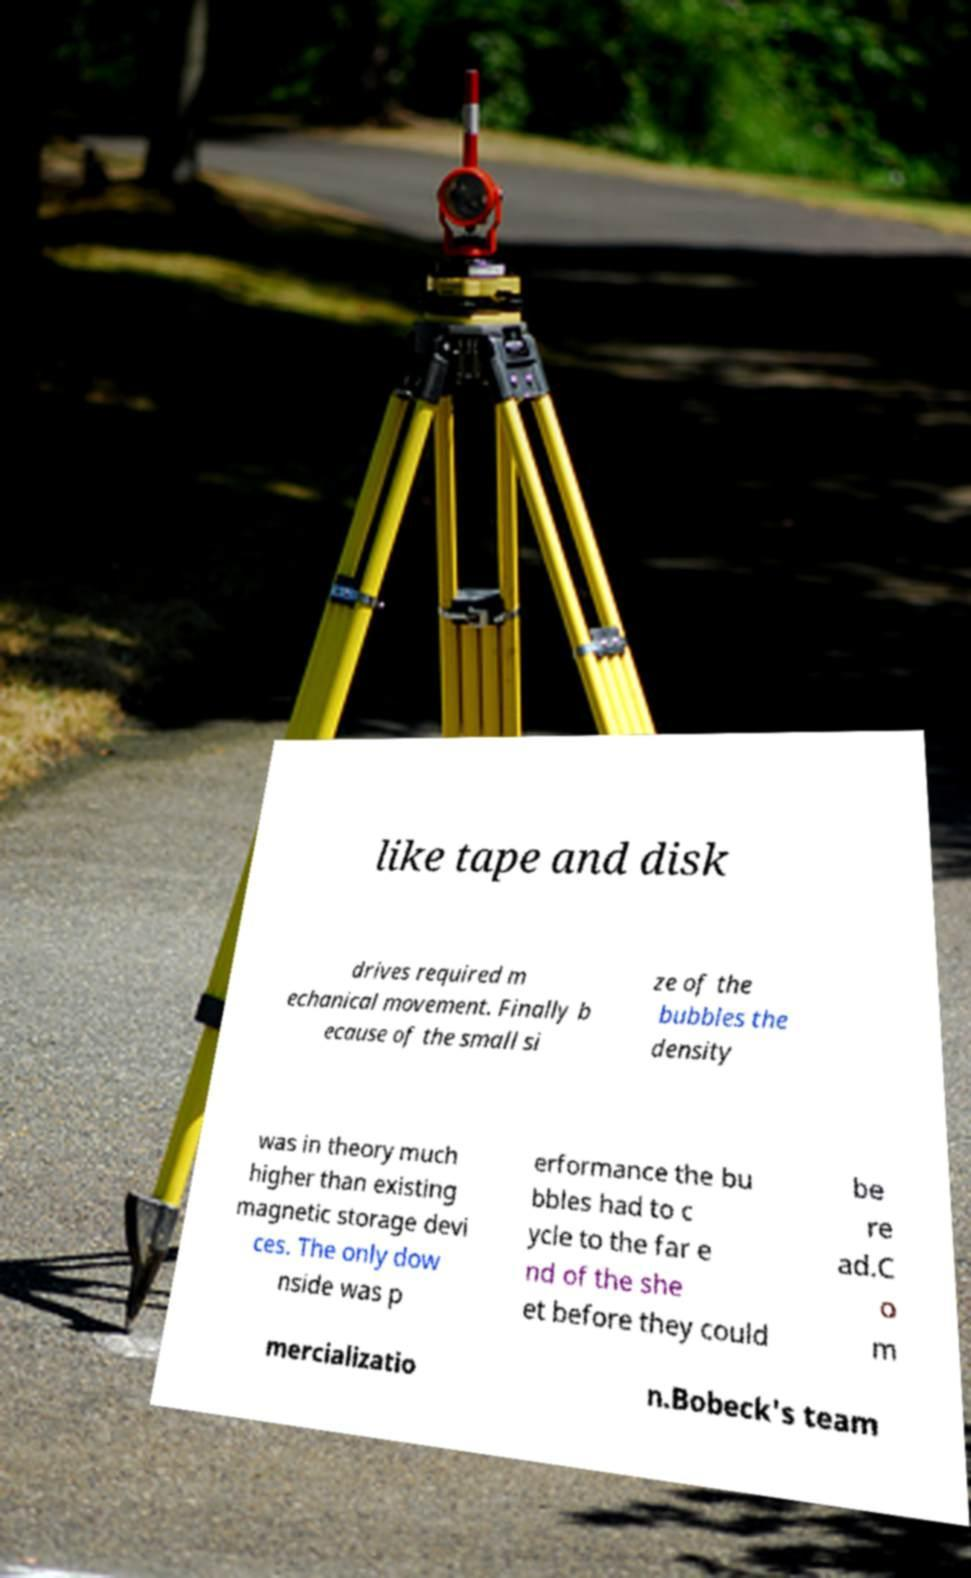For documentation purposes, I need the text within this image transcribed. Could you provide that? like tape and disk drives required m echanical movement. Finally b ecause of the small si ze of the bubbles the density was in theory much higher than existing magnetic storage devi ces. The only dow nside was p erformance the bu bbles had to c ycle to the far e nd of the she et before they could be re ad.C o m mercializatio n.Bobeck's team 